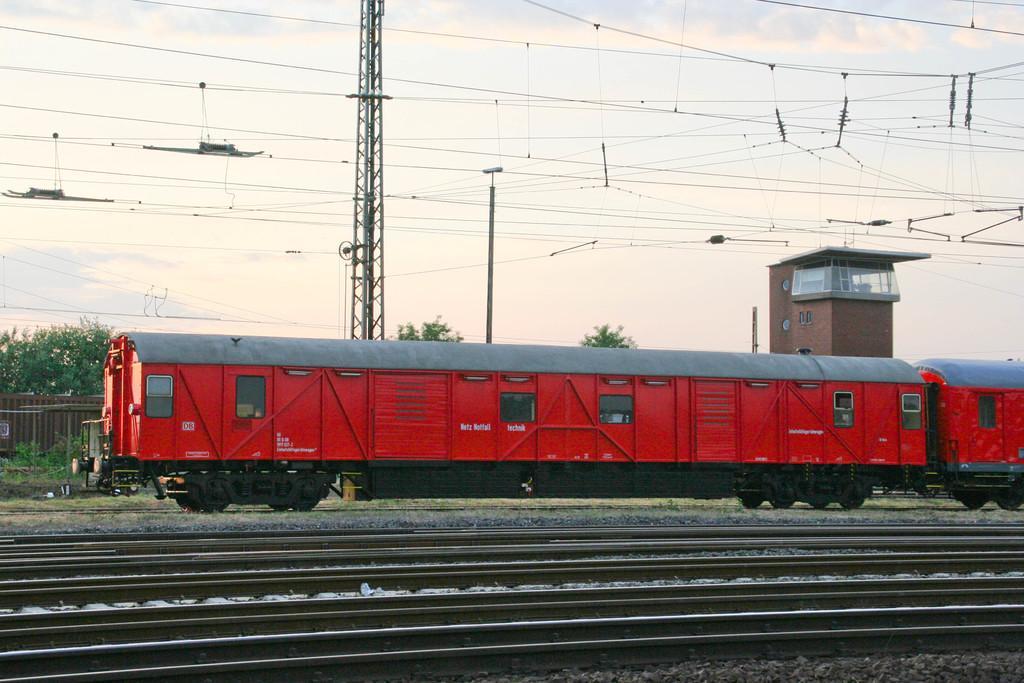Could you give a brief overview of what you see in this image? In this image we can see a train. Behind the train we can see a group of trees, a building, tower and a wooden fence. At the bottom we can see railway tracks. At the top we can see the sky and a group of wires. 